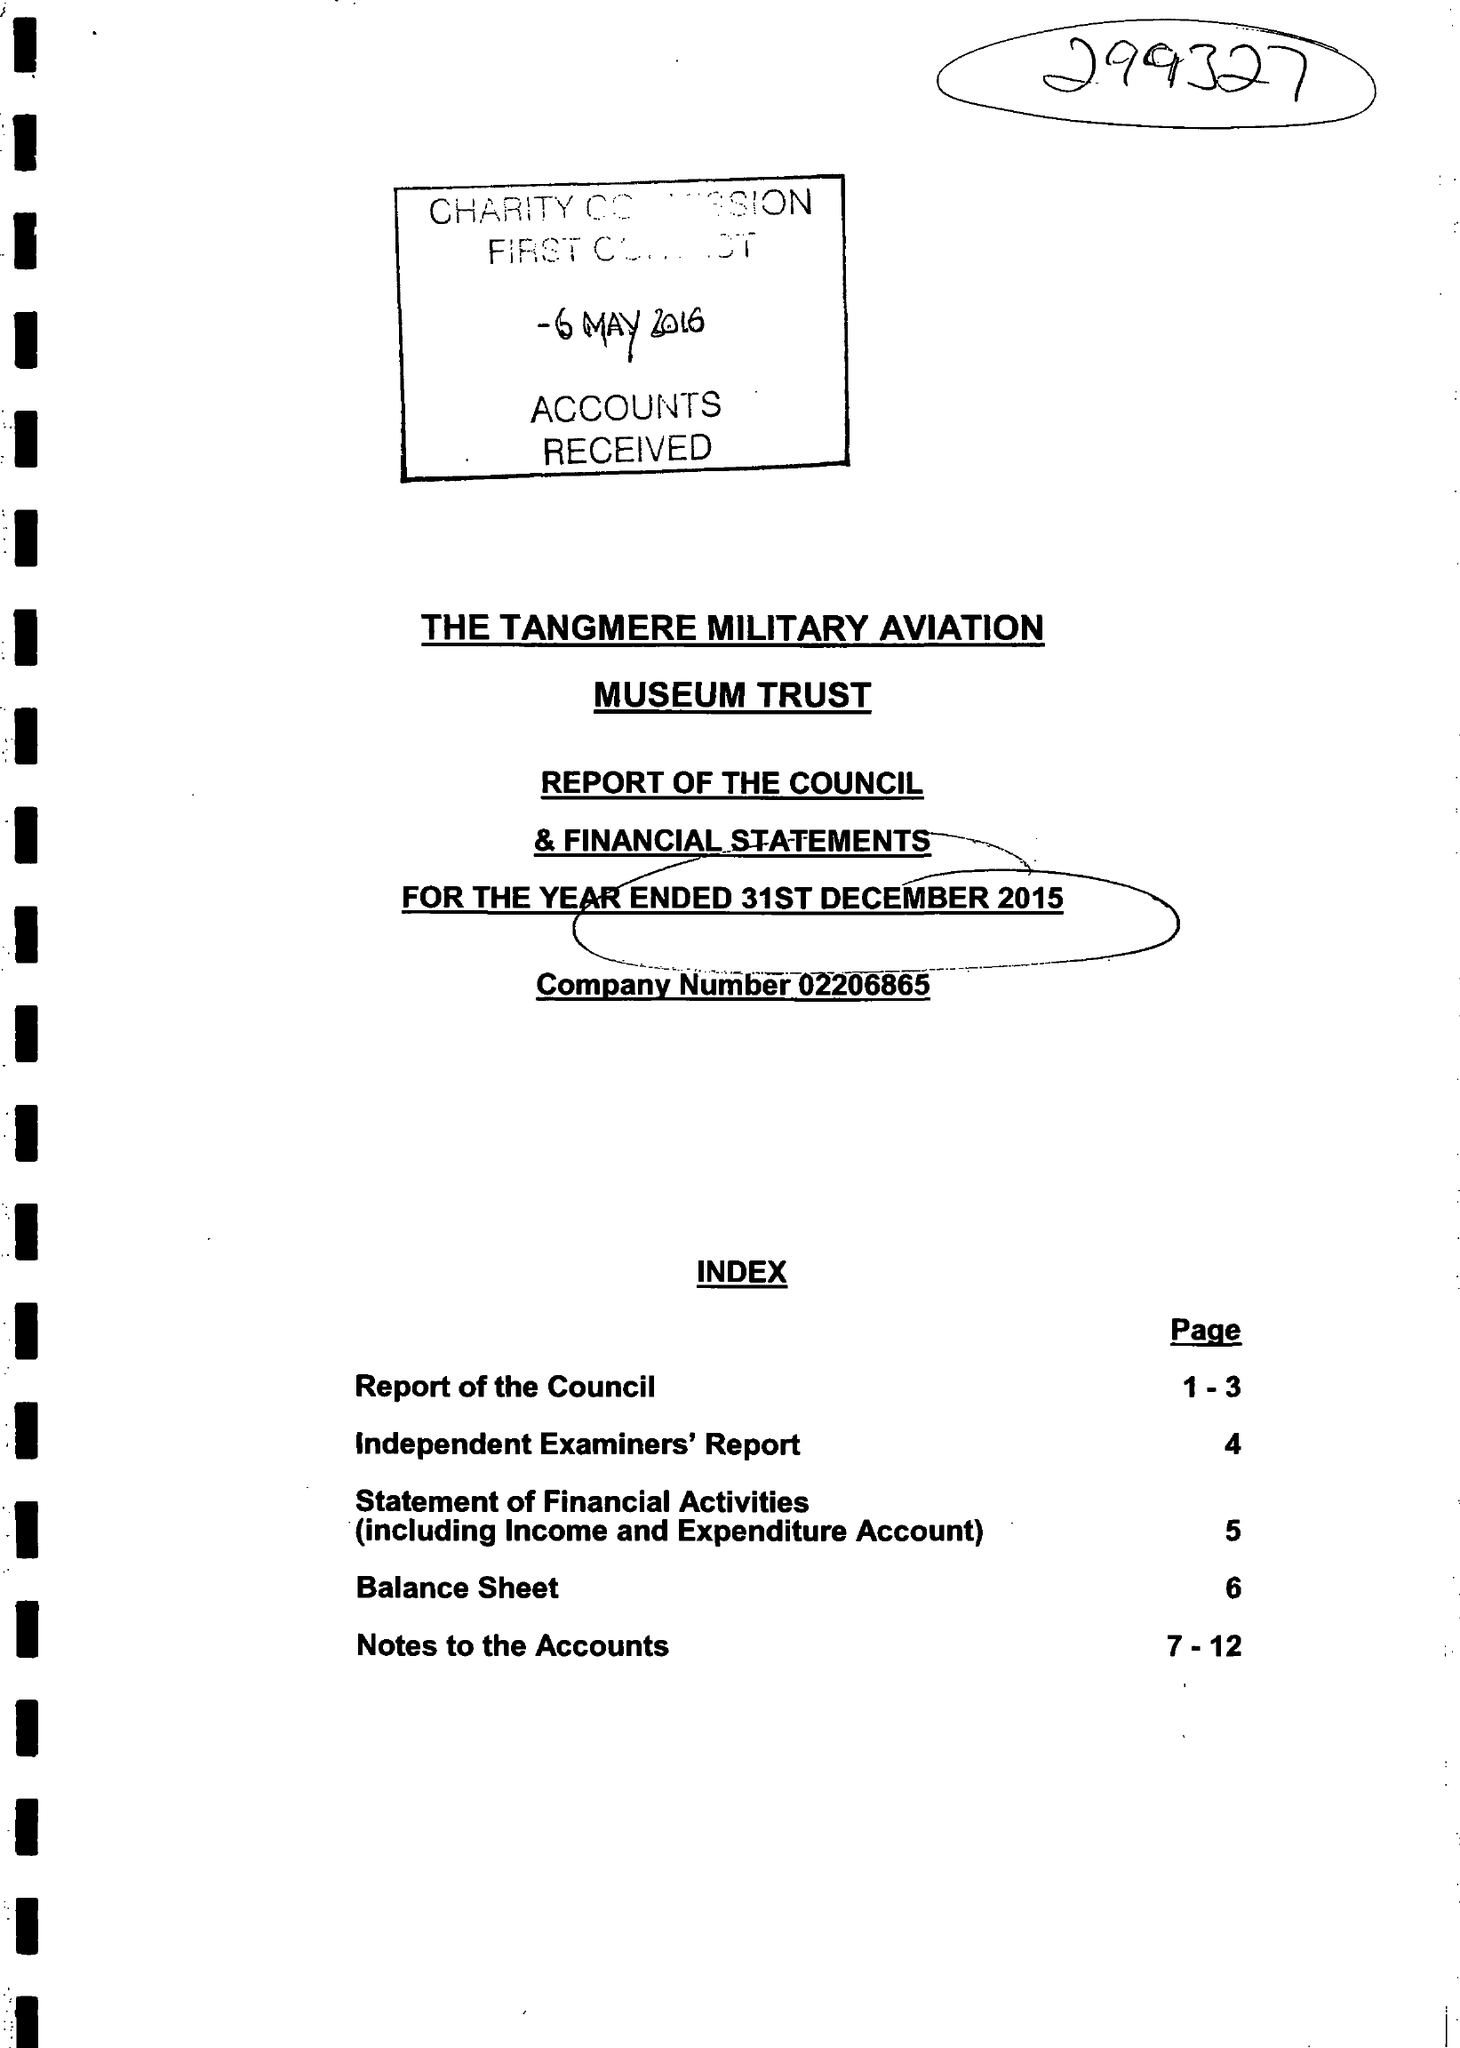What is the value for the report_date?
Answer the question using a single word or phrase. 2015-12-31 